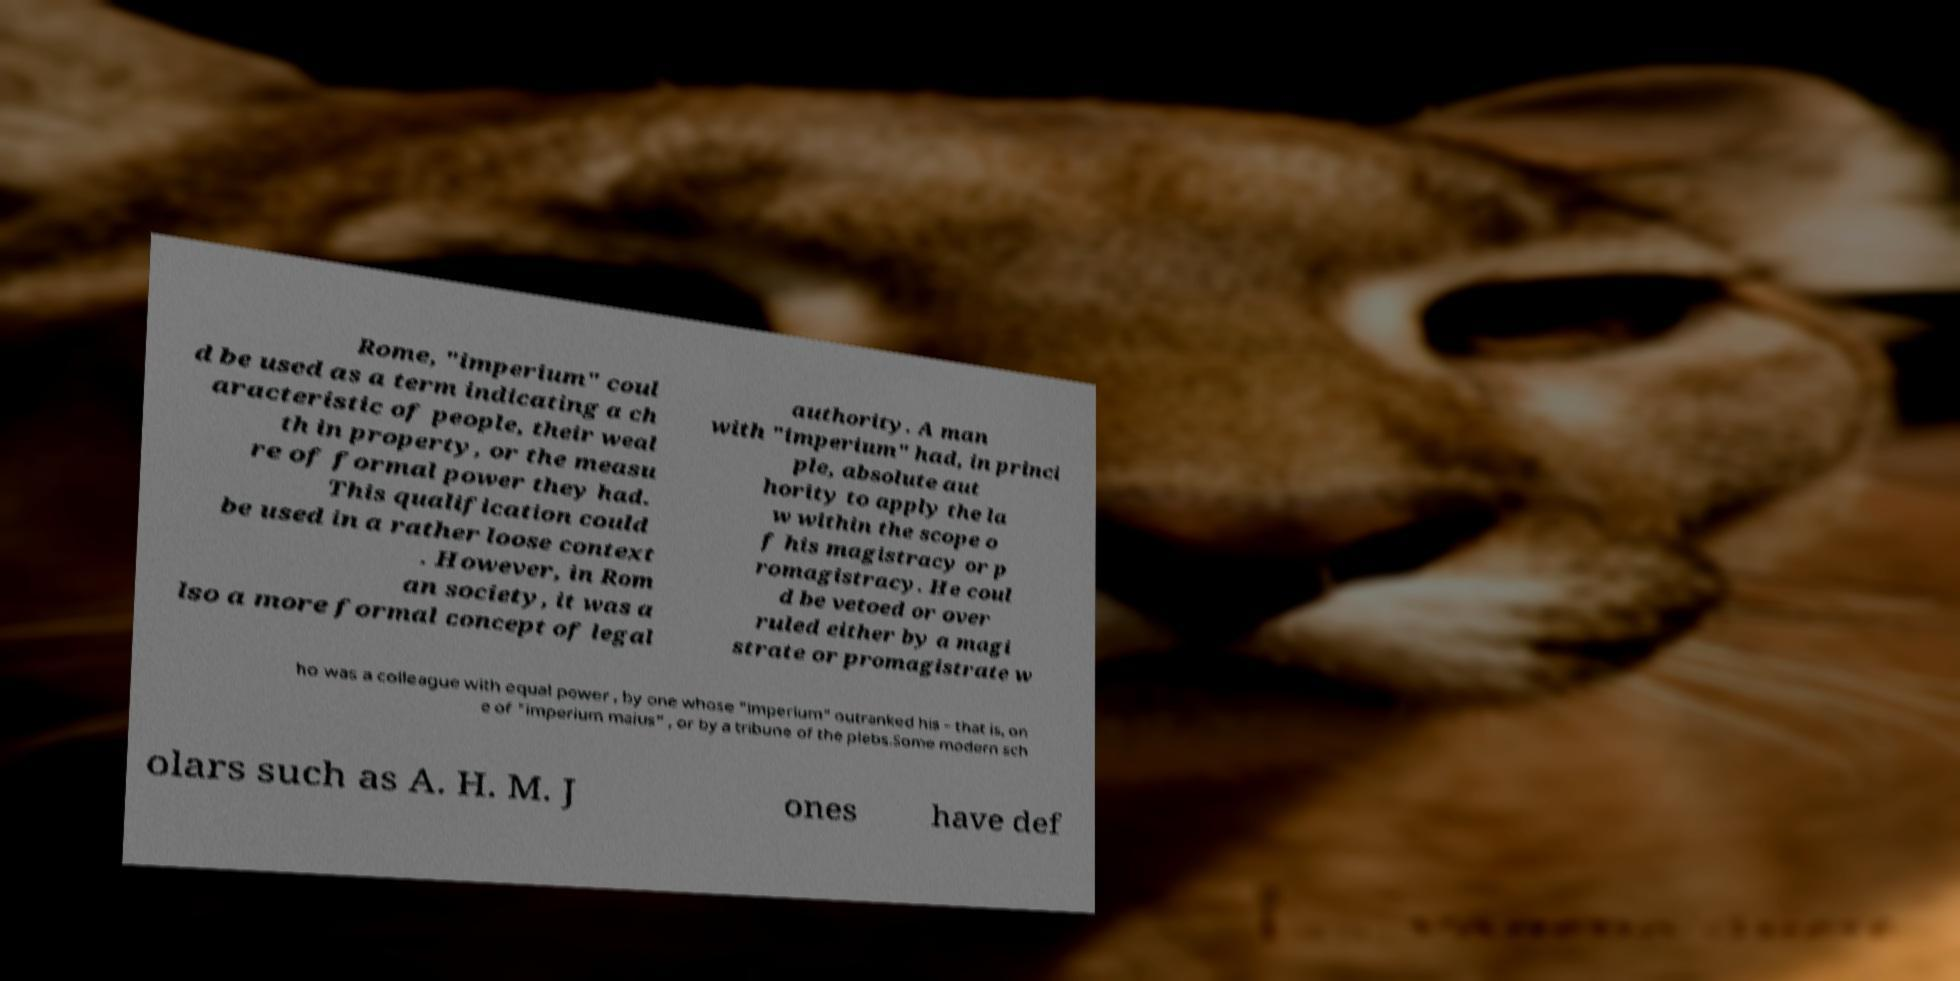Can you accurately transcribe the text from the provided image for me? Rome, "imperium" coul d be used as a term indicating a ch aracteristic of people, their weal th in property, or the measu re of formal power they had. This qualification could be used in a rather loose context . However, in Rom an society, it was a lso a more formal concept of legal authority. A man with "imperium" had, in princi ple, absolute aut hority to apply the la w within the scope o f his magistracy or p romagistracy. He coul d be vetoed or over ruled either by a magi strate or promagistrate w ho was a colleague with equal power , by one whose "imperium" outranked his – that is, on e of "imperium maius" , or by a tribune of the plebs.Some modern sch olars such as A. H. M. J ones have def 